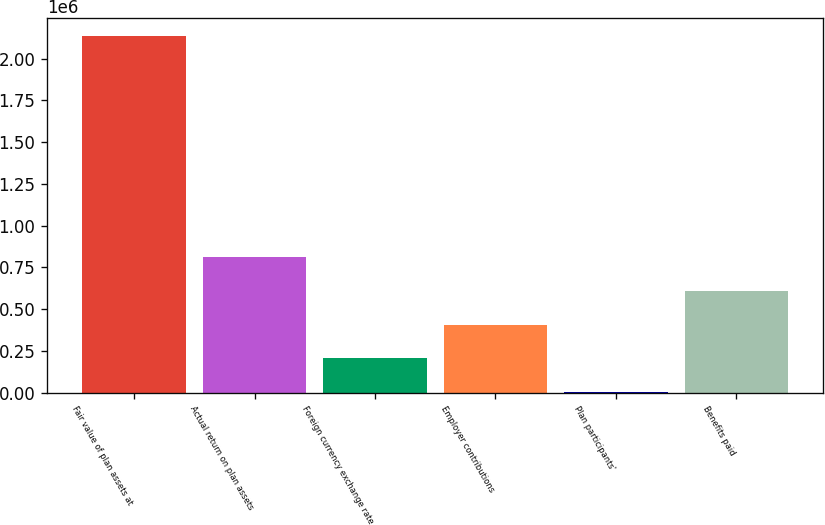<chart> <loc_0><loc_0><loc_500><loc_500><bar_chart><fcel>Fair value of plan assets at<fcel>Actual return on plan assets<fcel>Foreign currency exchange rate<fcel>Employer contributions<fcel>Plan participants'<fcel>Benefits paid<nl><fcel>2.13489e+06<fcel>810850<fcel>205357<fcel>407188<fcel>3526<fcel>609019<nl></chart> 